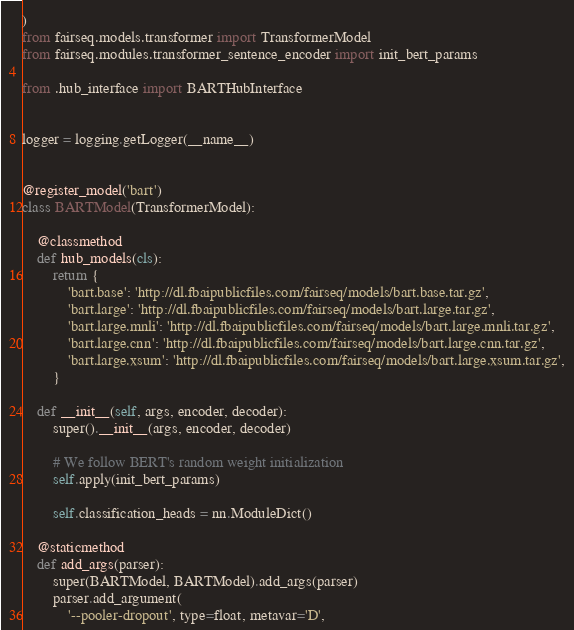Convert code to text. <code><loc_0><loc_0><loc_500><loc_500><_Python_>)
from fairseq.models.transformer import TransformerModel
from fairseq.modules.transformer_sentence_encoder import init_bert_params

from .hub_interface import BARTHubInterface


logger = logging.getLogger(__name__)


@register_model('bart')
class BARTModel(TransformerModel):

    @classmethod
    def hub_models(cls):
        return {
            'bart.base': 'http://dl.fbaipublicfiles.com/fairseq/models/bart.base.tar.gz',
            'bart.large': 'http://dl.fbaipublicfiles.com/fairseq/models/bart.large.tar.gz',
            'bart.large.mnli': 'http://dl.fbaipublicfiles.com/fairseq/models/bart.large.mnli.tar.gz',
            'bart.large.cnn': 'http://dl.fbaipublicfiles.com/fairseq/models/bart.large.cnn.tar.gz',
            'bart.large.xsum': 'http://dl.fbaipublicfiles.com/fairseq/models/bart.large.xsum.tar.gz',
        }

    def __init__(self, args, encoder, decoder):
        super().__init__(args, encoder, decoder)

        # We follow BERT's random weight initialization
        self.apply(init_bert_params)

        self.classification_heads = nn.ModuleDict()

    @staticmethod
    def add_args(parser):
        super(BARTModel, BARTModel).add_args(parser)
        parser.add_argument(
            '--pooler-dropout', type=float, metavar='D',</code> 